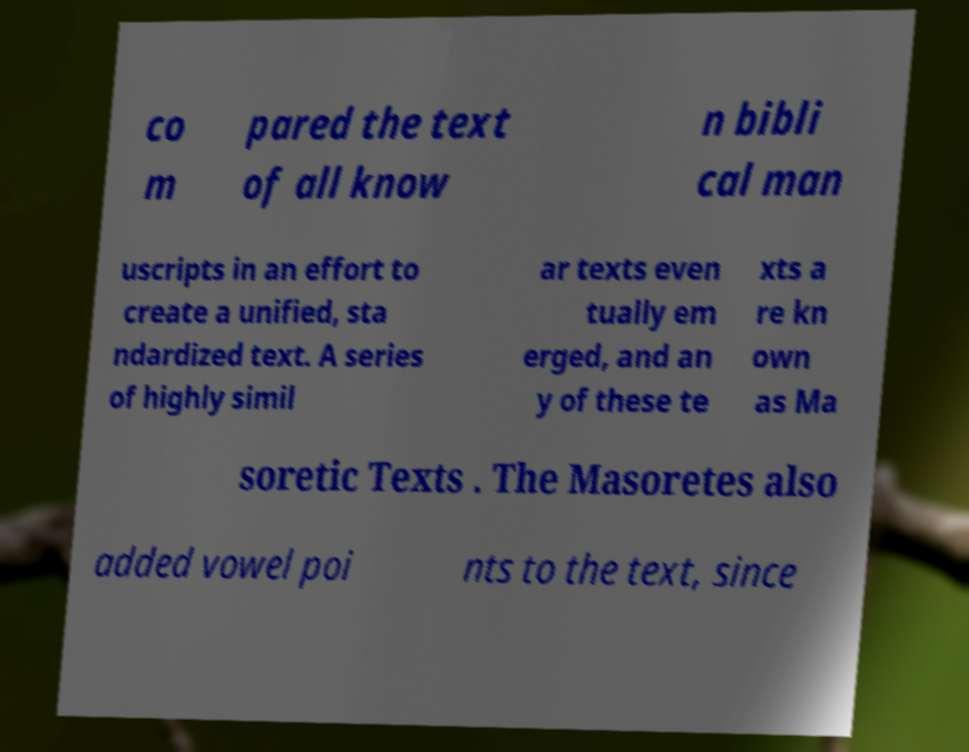There's text embedded in this image that I need extracted. Can you transcribe it verbatim? co m pared the text of all know n bibli cal man uscripts in an effort to create a unified, sta ndardized text. A series of highly simil ar texts even tually em erged, and an y of these te xts a re kn own as Ma soretic Texts . The Masoretes also added vowel poi nts to the text, since 